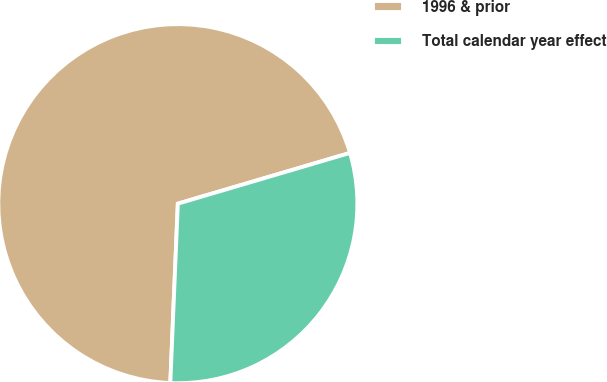Convert chart. <chart><loc_0><loc_0><loc_500><loc_500><pie_chart><fcel>1996 & prior<fcel>Total calendar year effect<nl><fcel>69.77%<fcel>30.23%<nl></chart> 